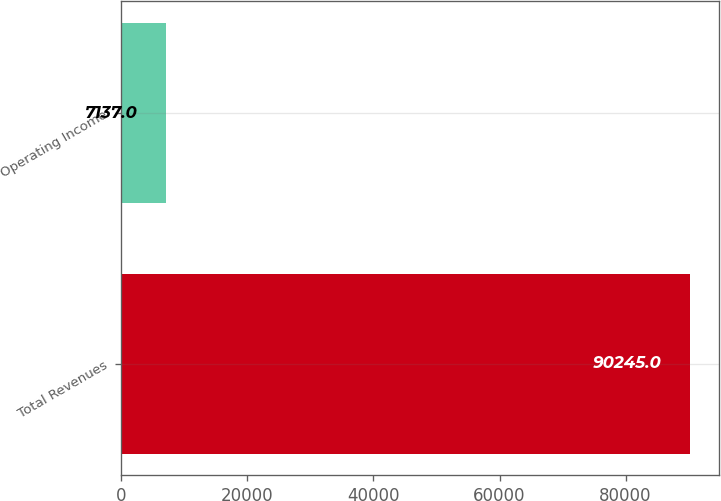Convert chart. <chart><loc_0><loc_0><loc_500><loc_500><bar_chart><fcel>Total Revenues<fcel>Operating Income<nl><fcel>90245<fcel>7137<nl></chart> 